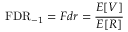<formula> <loc_0><loc_0><loc_500><loc_500>F D R _ { - 1 } = F d r = { \frac { E [ V ] } { E [ R ] } }</formula> 